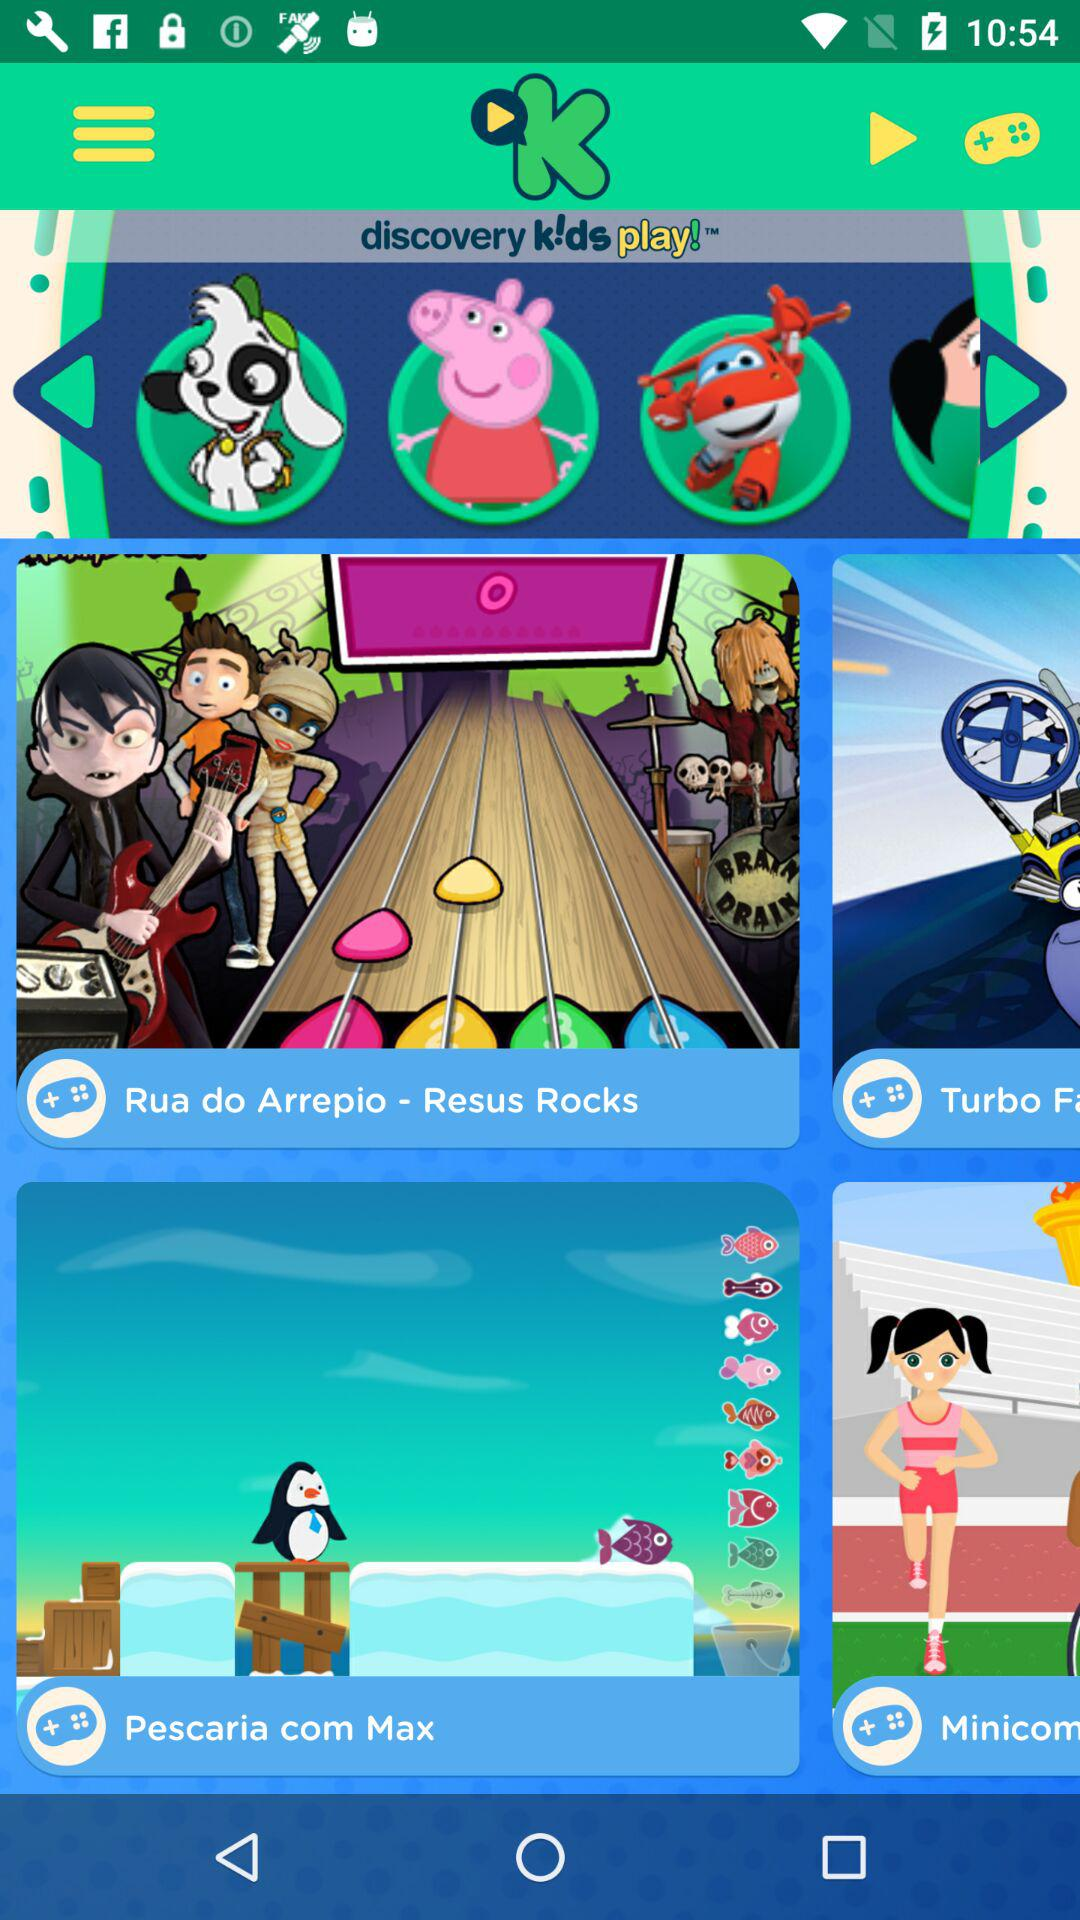What is the application name? The application name is "discovery k!ds play!". 